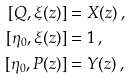<formula> <loc_0><loc_0><loc_500><loc_500>[ Q , \xi ( z ) ] & = X ( z ) \, , \\ [ \eta _ { 0 } , \xi ( z ) ] & = 1 \, , \\ [ \eta _ { 0 } , P ( z ) ] & = Y ( z ) \, ,</formula> 